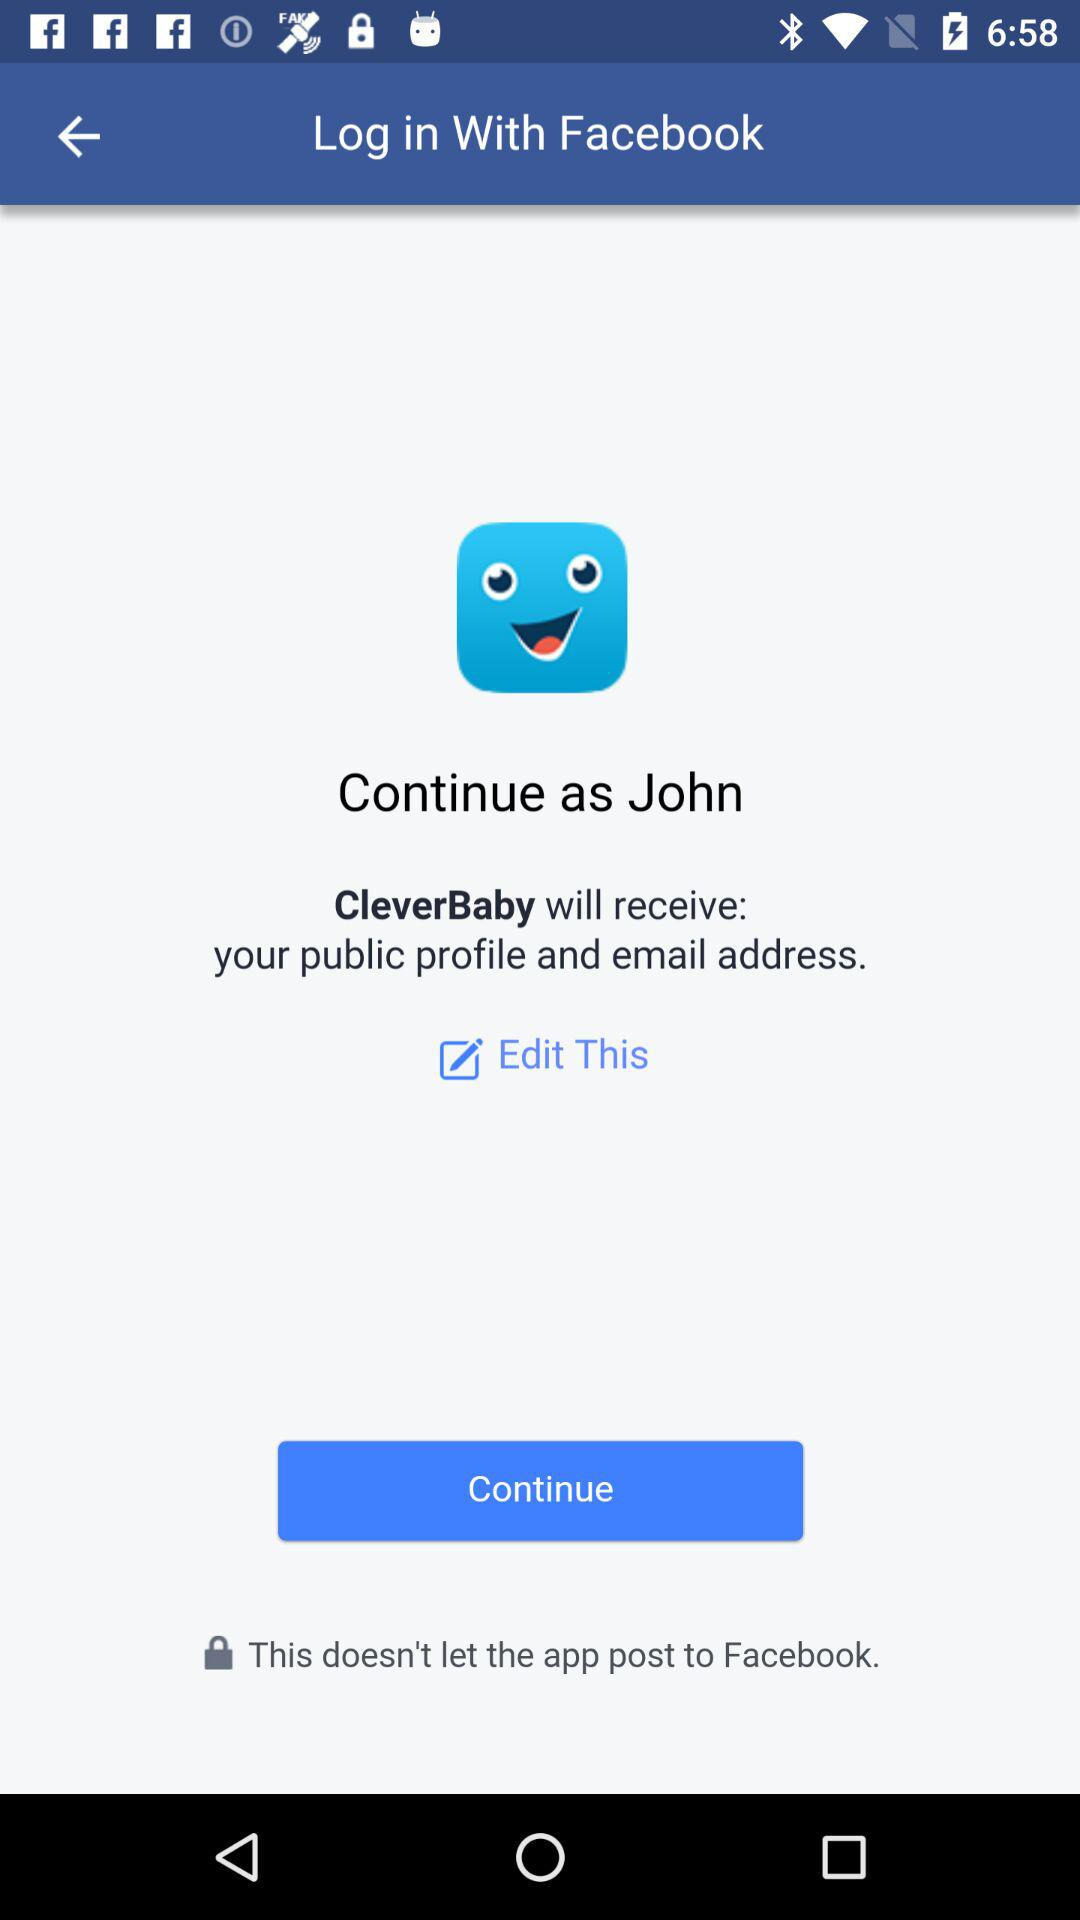What application is asking for permission? The application asking for permission is "CleverBaby". 